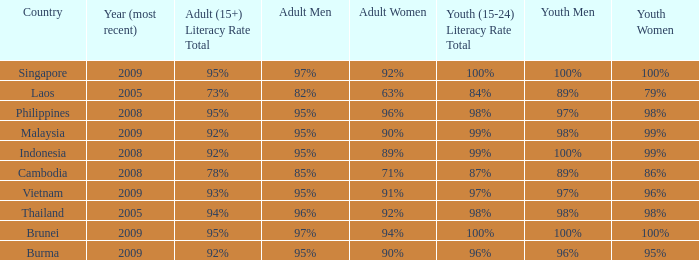Which country has a Youth (15-24) Literacy Rate Total of 100% and has an Adult Women Literacy rate of 92%? Singapore. 